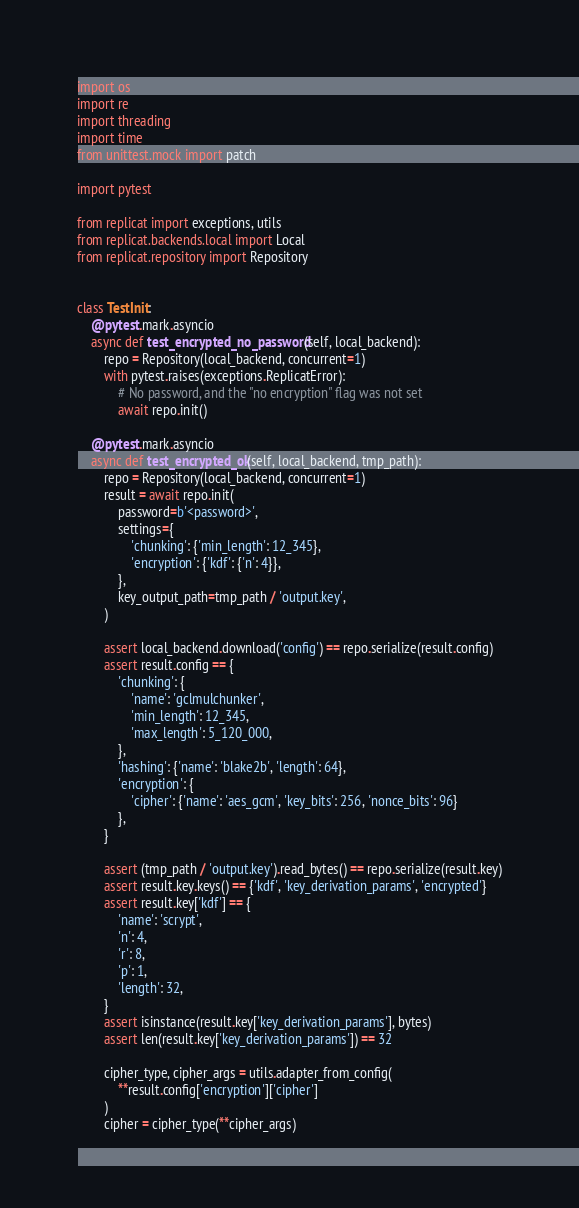Convert code to text. <code><loc_0><loc_0><loc_500><loc_500><_Python_>import os
import re
import threading
import time
from unittest.mock import patch

import pytest

from replicat import exceptions, utils
from replicat.backends.local import Local
from replicat.repository import Repository


class TestInit:
    @pytest.mark.asyncio
    async def test_encrypted_no_password(self, local_backend):
        repo = Repository(local_backend, concurrent=1)
        with pytest.raises(exceptions.ReplicatError):
            # No password, and the "no encryption" flag was not set
            await repo.init()

    @pytest.mark.asyncio
    async def test_encrypted_ok(self, local_backend, tmp_path):
        repo = Repository(local_backend, concurrent=1)
        result = await repo.init(
            password=b'<password>',
            settings={
                'chunking': {'min_length': 12_345},
                'encryption': {'kdf': {'n': 4}},
            },
            key_output_path=tmp_path / 'output.key',
        )

        assert local_backend.download('config') == repo.serialize(result.config)
        assert result.config == {
            'chunking': {
                'name': 'gclmulchunker',
                'min_length': 12_345,
                'max_length': 5_120_000,
            },
            'hashing': {'name': 'blake2b', 'length': 64},
            'encryption': {
                'cipher': {'name': 'aes_gcm', 'key_bits': 256, 'nonce_bits': 96}
            },
        }

        assert (tmp_path / 'output.key').read_bytes() == repo.serialize(result.key)
        assert result.key.keys() == {'kdf', 'key_derivation_params', 'encrypted'}
        assert result.key['kdf'] == {
            'name': 'scrypt',
            'n': 4,
            'r': 8,
            'p': 1,
            'length': 32,
        }
        assert isinstance(result.key['key_derivation_params'], bytes)
        assert len(result.key['key_derivation_params']) == 32

        cipher_type, cipher_args = utils.adapter_from_config(
            **result.config['encryption']['cipher']
        )
        cipher = cipher_type(**cipher_args)
</code> 